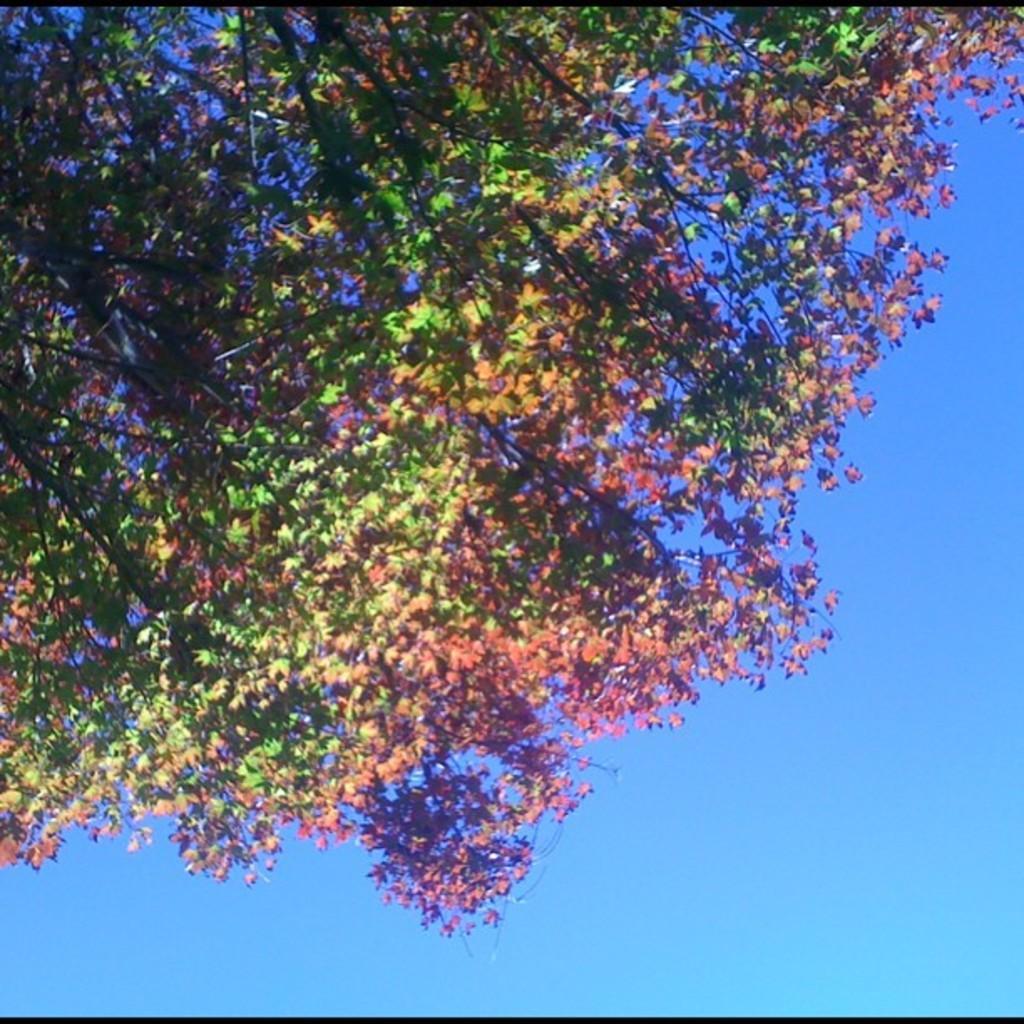In one or two sentences, can you explain what this image depicts? In this image we can see a tree. Behind the tree, we can see the sky. 